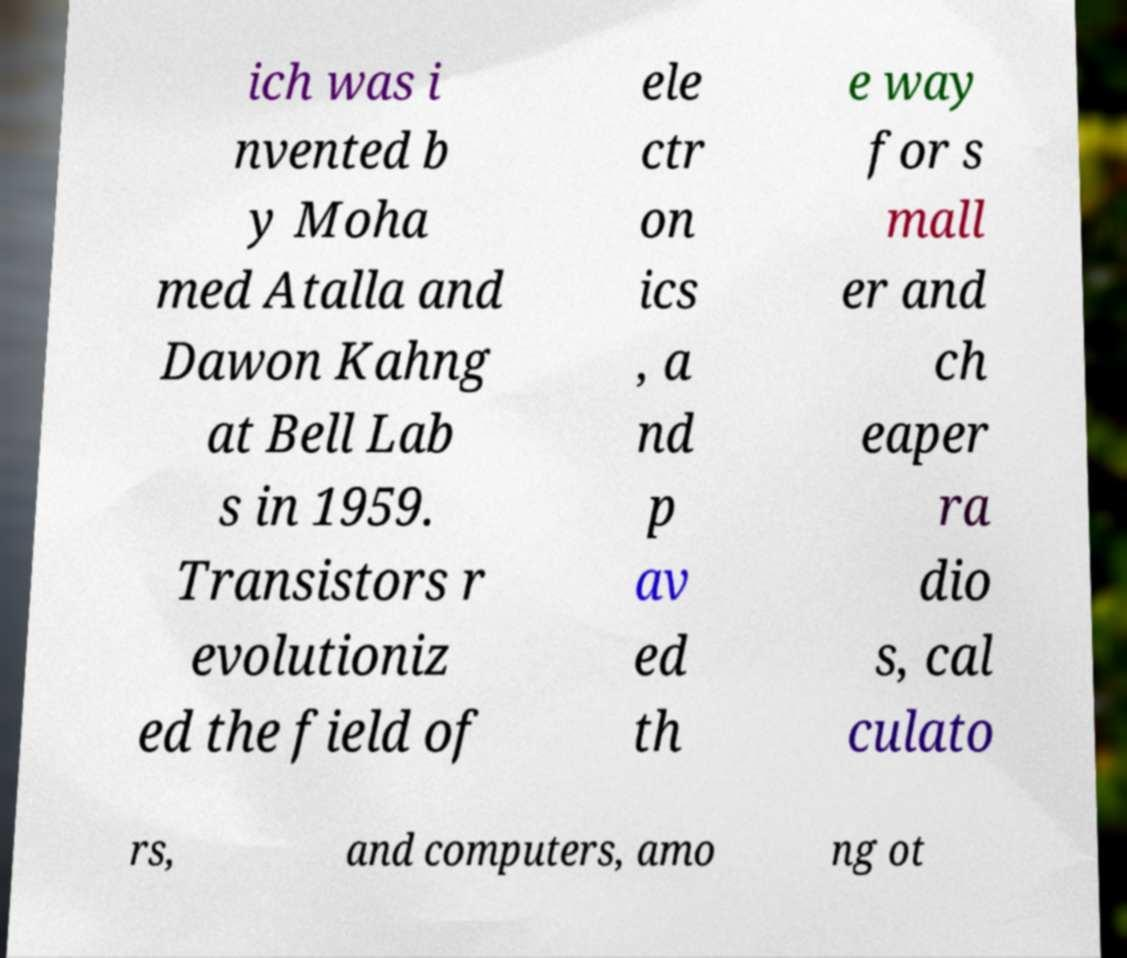Please identify and transcribe the text found in this image. ich was i nvented b y Moha med Atalla and Dawon Kahng at Bell Lab s in 1959. Transistors r evolutioniz ed the field of ele ctr on ics , a nd p av ed th e way for s mall er and ch eaper ra dio s, cal culato rs, and computers, amo ng ot 